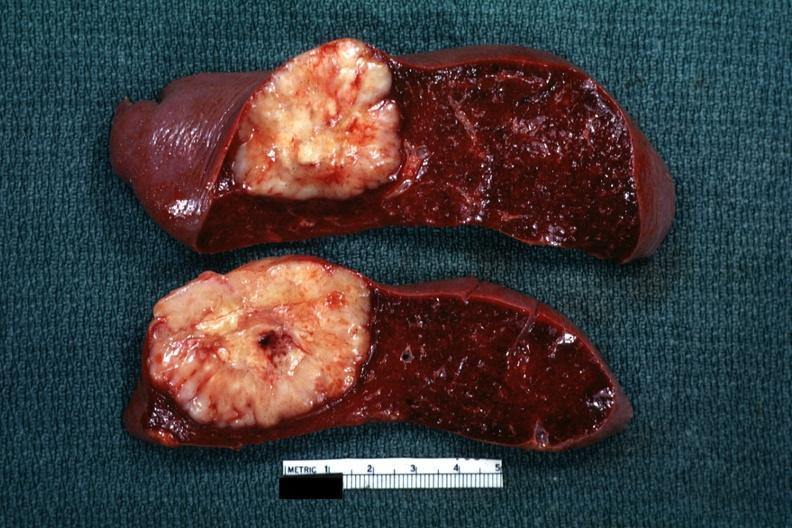s chronic myelogenous leukemia present?
Answer the question using a single word or phrase. No 